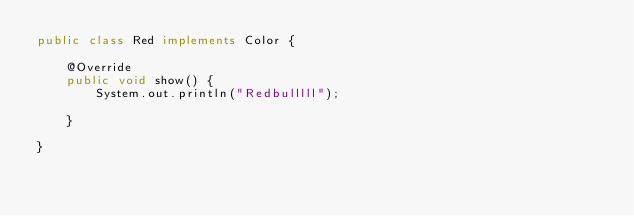<code> <loc_0><loc_0><loc_500><loc_500><_Java_>public class Red implements Color {

	@Override
	public void show() {
		System.out.println("Redbulllll");
		
	}
    
}
</code> 